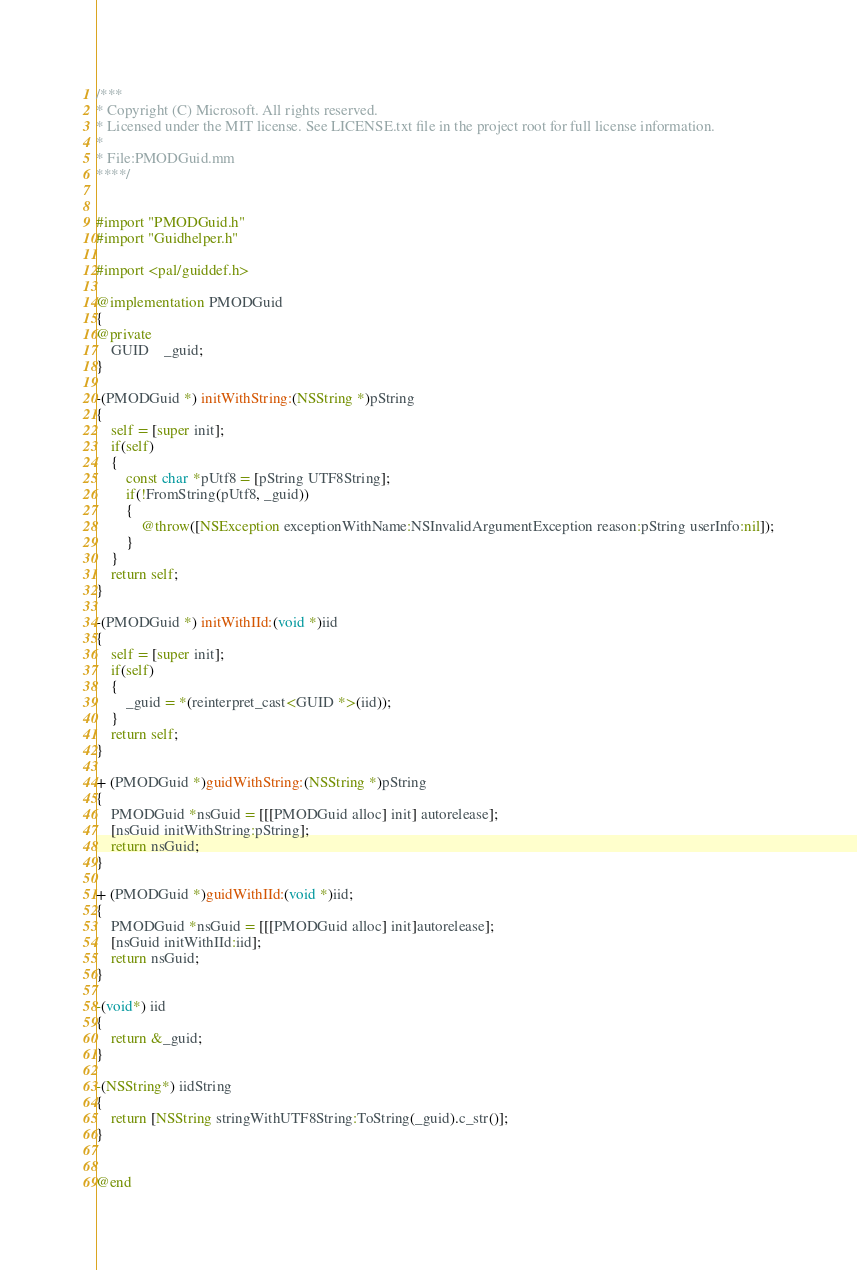<code> <loc_0><loc_0><loc_500><loc_500><_ObjectiveC_>/***
* Copyright (C) Microsoft. All rights reserved.
* Licensed under the MIT license. See LICENSE.txt file in the project root for full license information.
*
* File:PMODGuid.mm
****/


#import "PMODGuid.h"
#import "Guidhelper.h"

#import <pal/guiddef.h>

@implementation PMODGuid
{
@private
    GUID	_guid;
}

-(PMODGuid *) initWithString:(NSString *)pString
{
	self = [super init];
	if(self)
	{
        const char *pUtf8 = [pString UTF8String];
        if(!FromString(pUtf8, _guid))
        {
            @throw([NSException exceptionWithName:NSInvalidArgumentException reason:pString userInfo:nil]);
        }
	}
	return self;
}

-(PMODGuid *) initWithIId:(void *)iid
{
	self = [super init];
	if(self)
	{
        _guid = *(reinterpret_cast<GUID *>(iid));
	}
	return self;
}

+ (PMODGuid *)guidWithString:(NSString *)pString
{
    PMODGuid *nsGuid = [[[PMODGuid alloc] init] autorelease];
    [nsGuid initWithString:pString];
    return nsGuid;
}

+ (PMODGuid *)guidWithIId:(void *)iid;
{
    PMODGuid *nsGuid = [[[PMODGuid alloc] init]autorelease];
    [nsGuid initWithIId:iid];
    return nsGuid;
}

-(void*) iid
{
    return &_guid;
}

-(NSString*) iidString
{
    return [NSString stringWithUTF8String:ToString(_guid).c_str()];
}


@end
</code> 